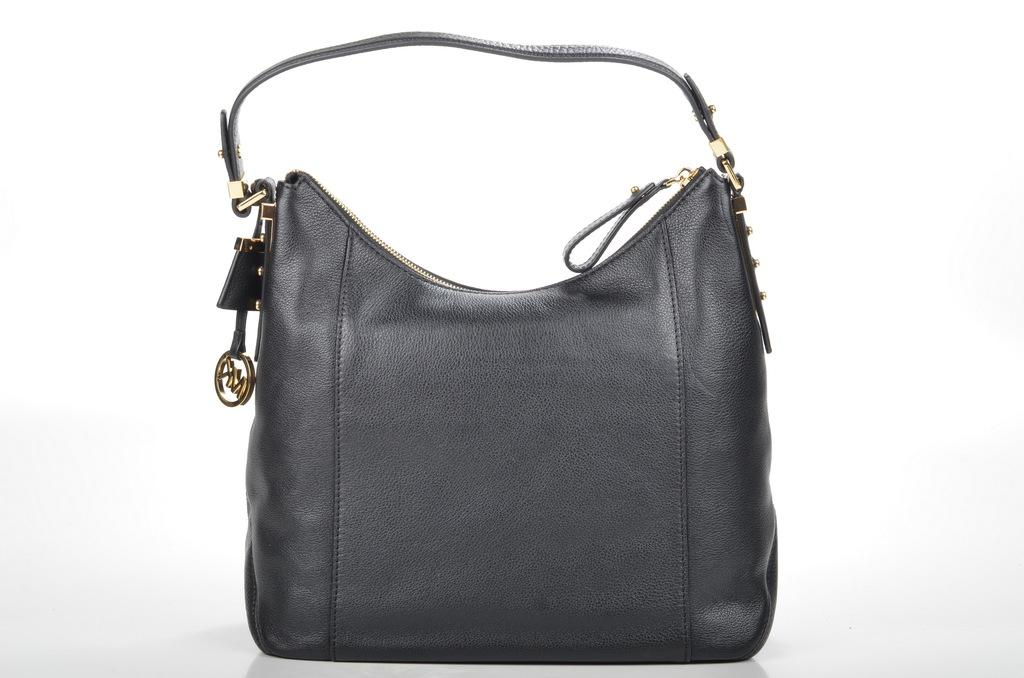What object can be seen in the picture? There is a bag in the picture. What is the color of the bag? The bag is black in color. Is there any feature that helps to carry the bag? Yes, there is a strap attached to the bag. What is written on the strap of the bag? The logo on the strap has the letters "MK" written on it. Can you see any blood stains on the bag in the image? No, there are no blood stains visible on the bag in the image. Is there a quill pen inside the bag? There is no information about the contents of the bag, including a quill pen, in the provided facts. 